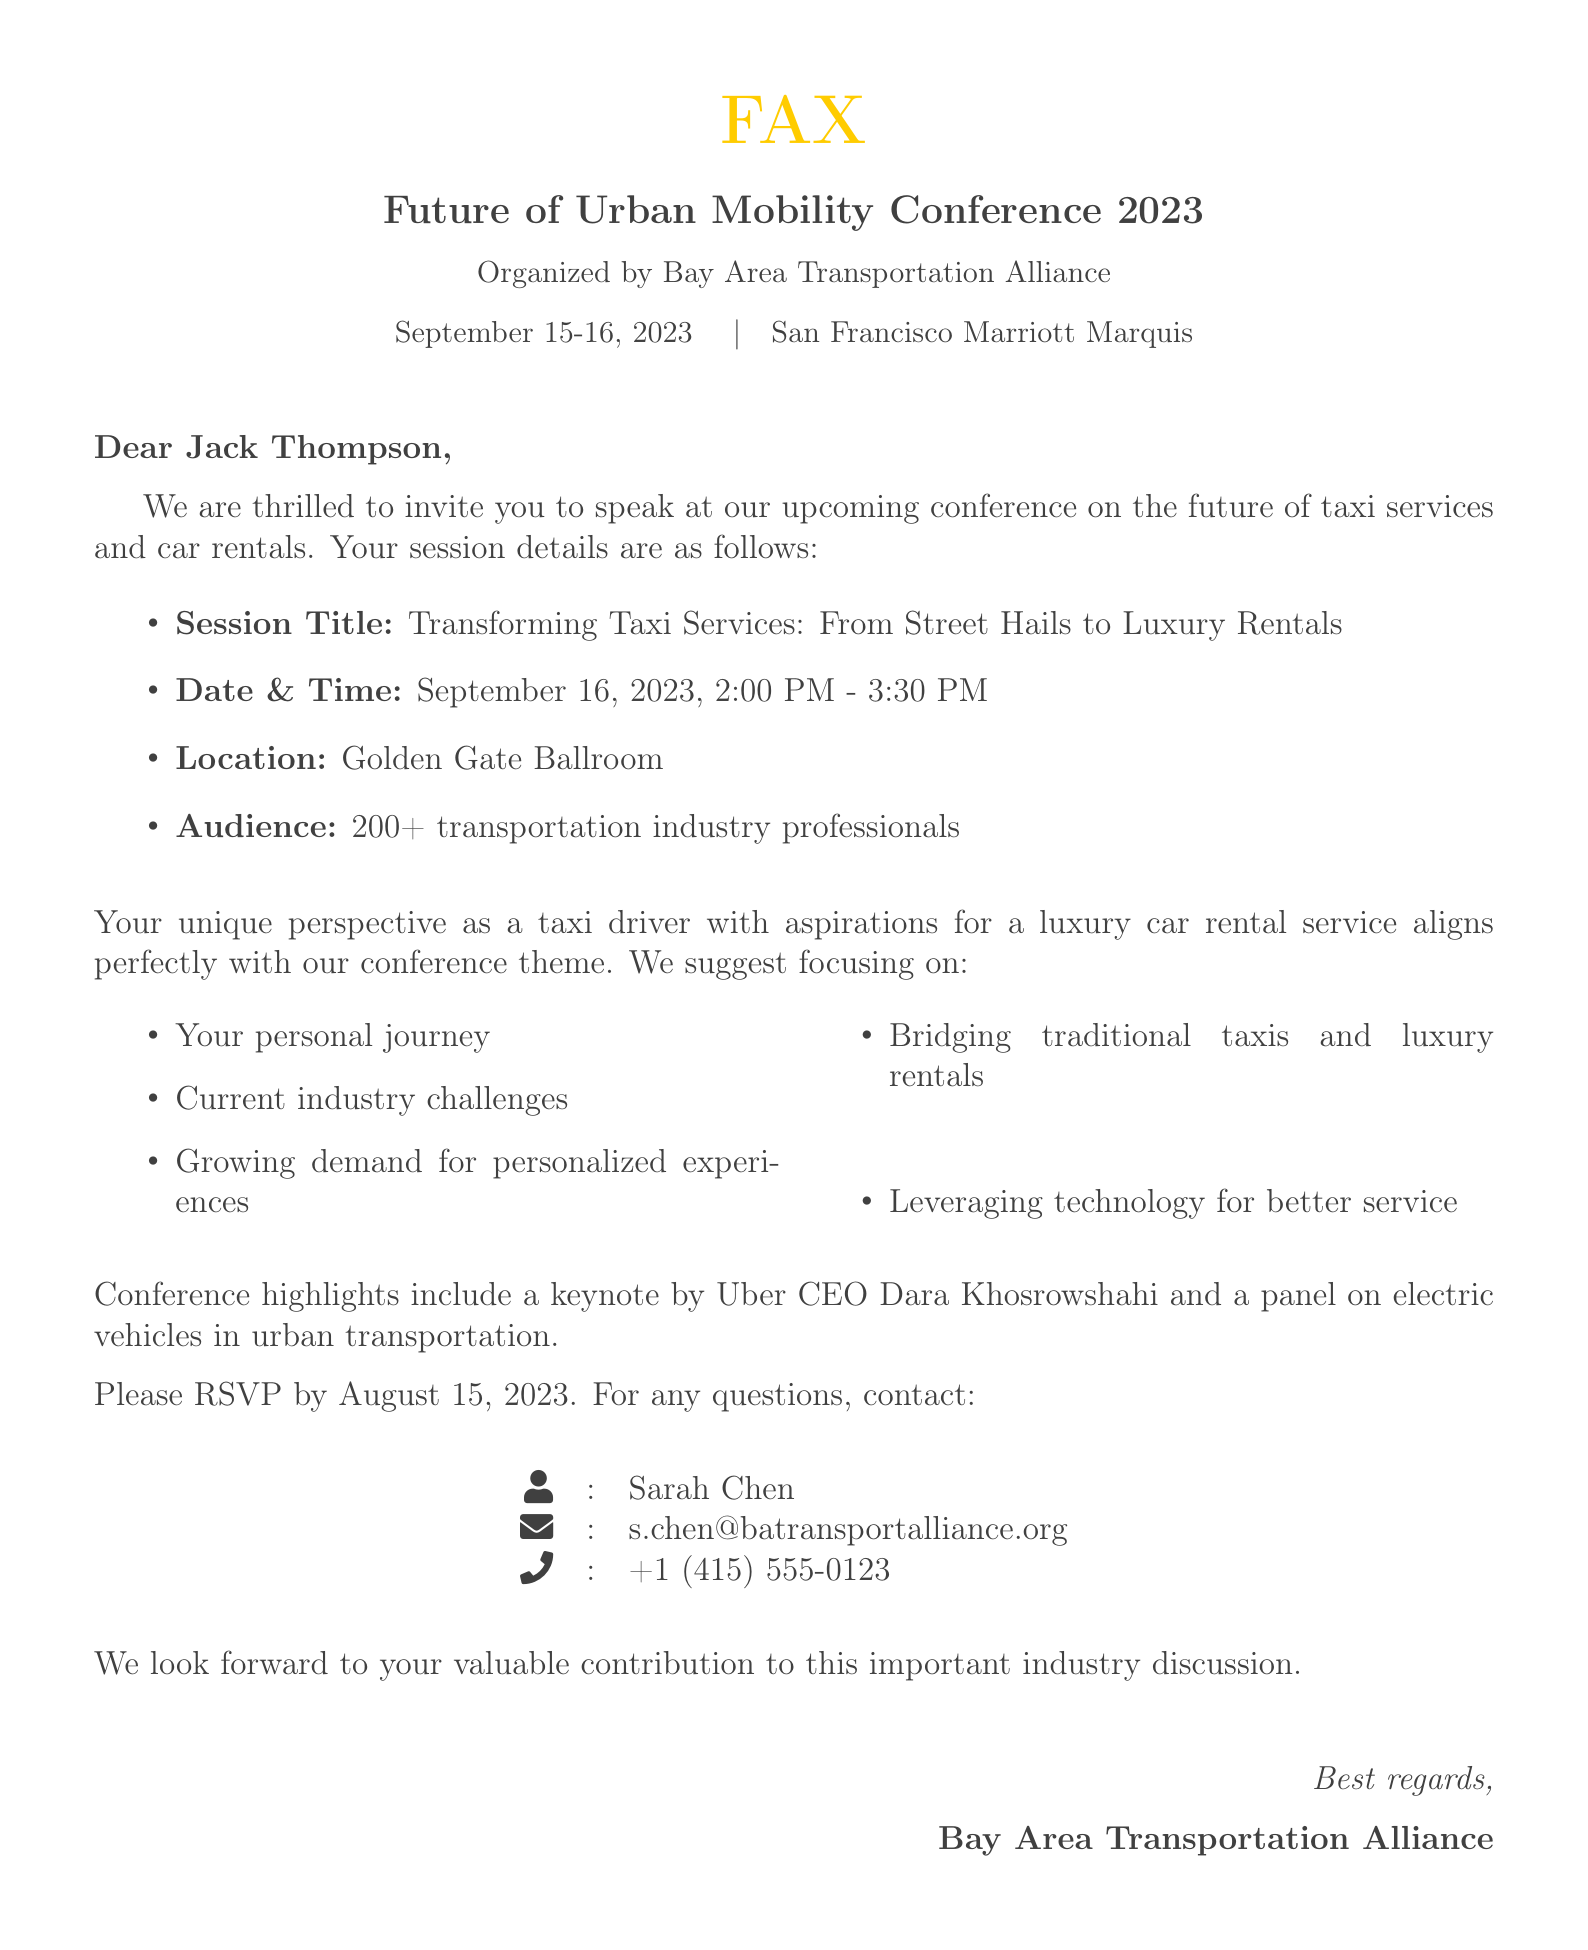What is the title of the session Jack Thompson will speak at? The session title is explicitly stated in the document as "Transforming Taxi Services: From Street Hails to Luxury Rentals."
Answer: Transforming Taxi Services: From Street Hails to Luxury Rentals What is the date and time of the speaking session? The document mentions the session will take place on September 16, 2023, from 2:00 PM to 3:30 PM.
Answer: September 16, 2023, 2:00 PM - 3:30 PM Where is the location of the session? The document specifies that the session will be held at the Golden Gate Ballroom.
Answer: Golden Gate Ballroom What is the audience size for the event? The document indicates that there will be 200+ transportation industry professionals in attendance.
Answer: 200+ Who is the organizer of the conference? The document states that the conference is organized by the Bay Area Transportation Alliance.
Answer: Bay Area Transportation Alliance What is one topic suggested for the speaking session? The document lists several suggested topics; one of them is "Your personal journey."
Answer: Your personal journey What is the RSVP deadline? The document mentions the RSVP deadline as August 15, 2023.
Answer: August 15, 2023 Who will give the keynote address? The document names Uber CEO Dara Khosrowshahi as the keynote speaker.
Answer: Dara Khosrowshahi What is one method mentioned for improving taxi services? The document suggests "Leveraging technology for better service" as a method for improvement.
Answer: Leveraging technology for better service 